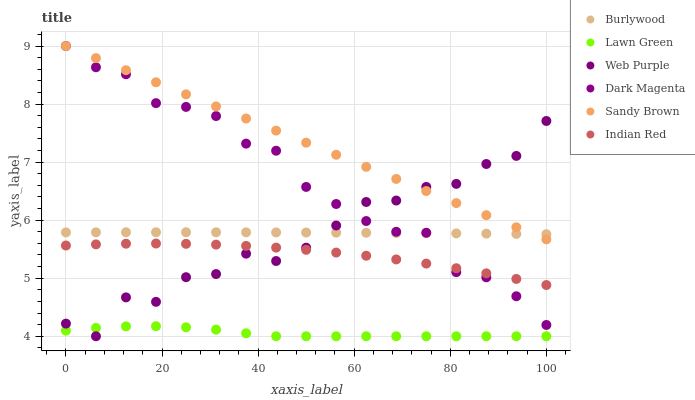Does Lawn Green have the minimum area under the curve?
Answer yes or no. Yes. Does Sandy Brown have the maximum area under the curve?
Answer yes or no. Yes. Does Dark Magenta have the minimum area under the curve?
Answer yes or no. No. Does Dark Magenta have the maximum area under the curve?
Answer yes or no. No. Is Sandy Brown the smoothest?
Answer yes or no. Yes. Is Web Purple the roughest?
Answer yes or no. Yes. Is Dark Magenta the smoothest?
Answer yes or no. No. Is Dark Magenta the roughest?
Answer yes or no. No. Does Lawn Green have the lowest value?
Answer yes or no. Yes. Does Dark Magenta have the lowest value?
Answer yes or no. No. Does Sandy Brown have the highest value?
Answer yes or no. Yes. Does Burlywood have the highest value?
Answer yes or no. No. Is Lawn Green less than Dark Magenta?
Answer yes or no. Yes. Is Burlywood greater than Indian Red?
Answer yes or no. Yes. Does Indian Red intersect Dark Magenta?
Answer yes or no. Yes. Is Indian Red less than Dark Magenta?
Answer yes or no. No. Is Indian Red greater than Dark Magenta?
Answer yes or no. No. Does Lawn Green intersect Dark Magenta?
Answer yes or no. No. 